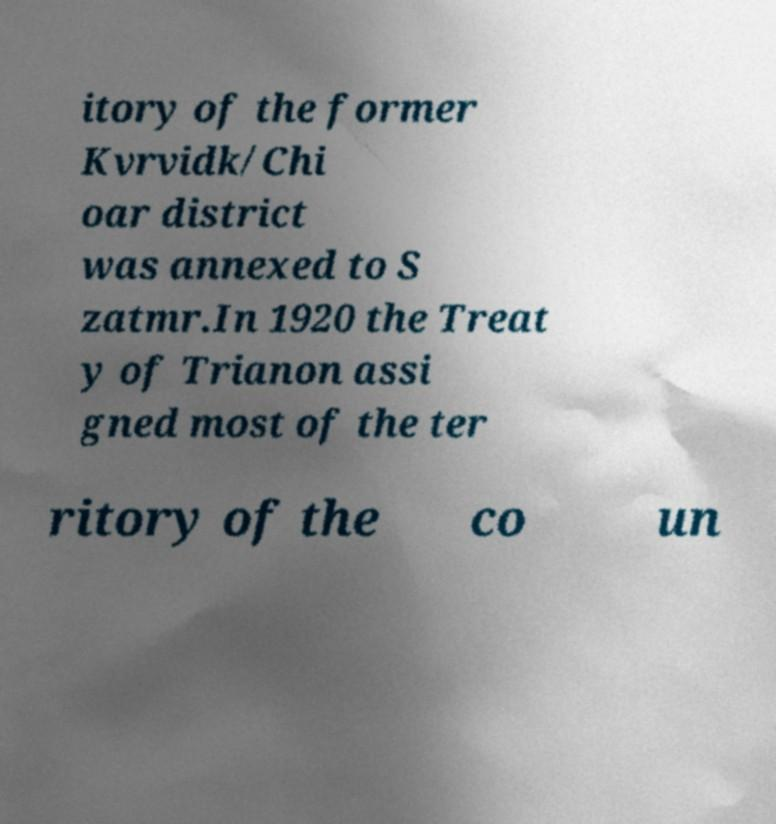Can you accurately transcribe the text from the provided image for me? itory of the former Kvrvidk/Chi oar district was annexed to S zatmr.In 1920 the Treat y of Trianon assi gned most of the ter ritory of the co un 